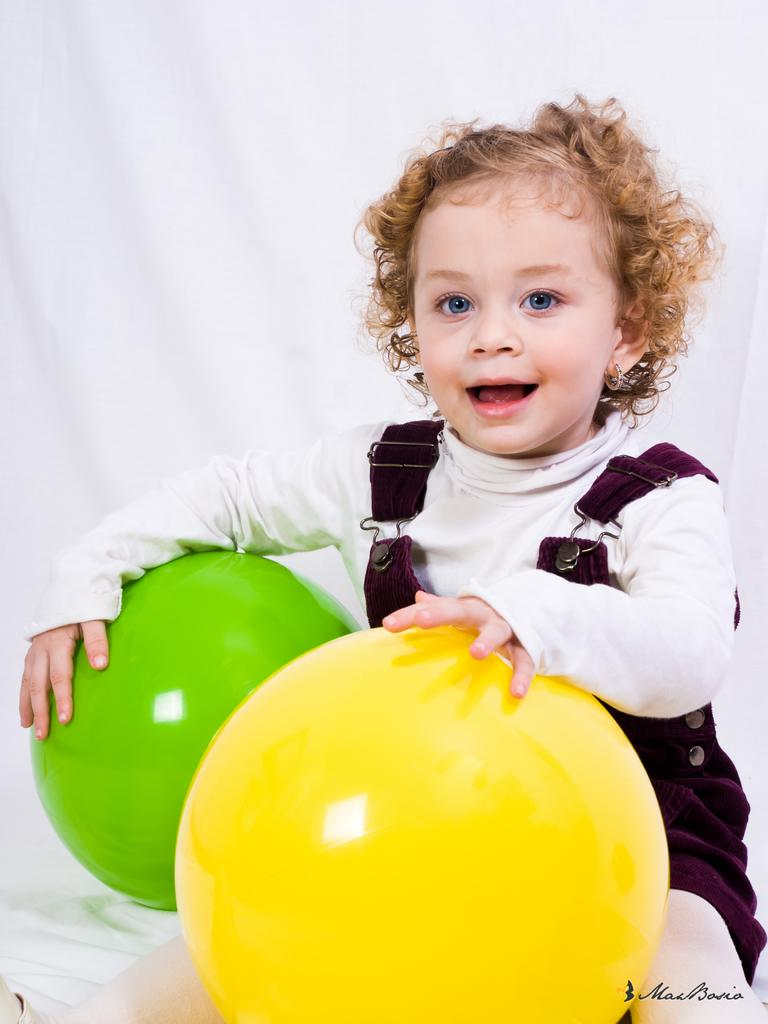What is the main subject of the image? The main subject of the image is a kid. What is the kid holding in the image? The kid is holding two balloons. What color is the background of the image? The background of the image is white. Is there any text present in the image? Yes, there is text on the image. What grade is the kid in, based on the image? There is no information about the kid's grade in the image. Is there a bomb present in the image? No, there is no bomb present in the image. 